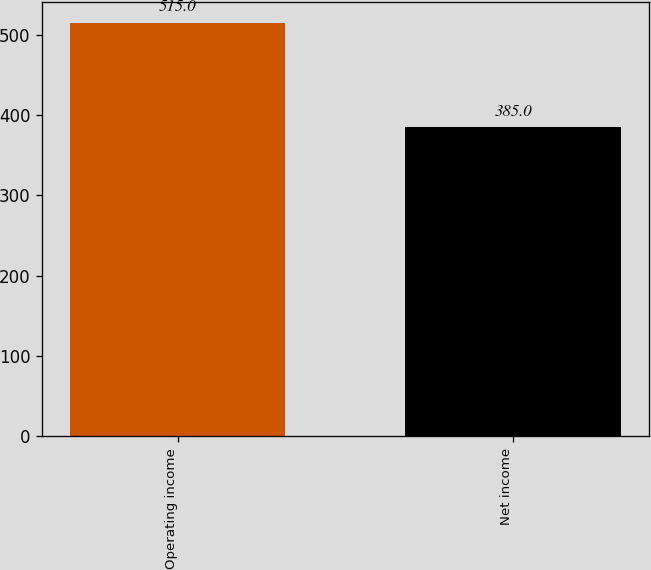<chart> <loc_0><loc_0><loc_500><loc_500><bar_chart><fcel>Operating income<fcel>Net income<nl><fcel>515<fcel>385<nl></chart> 